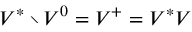<formula> <loc_0><loc_0><loc_500><loc_500>V ^ { * } \ V ^ { 0 } = V ^ { + } = V ^ { * } V</formula> 